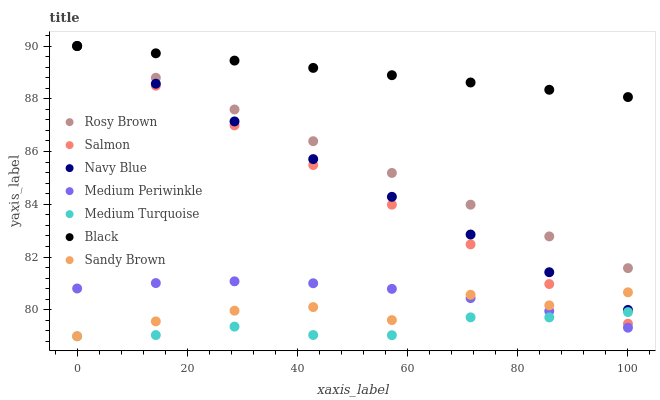Does Medium Turquoise have the minimum area under the curve?
Answer yes or no. Yes. Does Black have the maximum area under the curve?
Answer yes or no. Yes. Does Navy Blue have the minimum area under the curve?
Answer yes or no. No. Does Navy Blue have the maximum area under the curve?
Answer yes or no. No. Is Rosy Brown the smoothest?
Answer yes or no. Yes. Is Sandy Brown the roughest?
Answer yes or no. Yes. Is Navy Blue the smoothest?
Answer yes or no. No. Is Navy Blue the roughest?
Answer yes or no. No. Does Medium Turquoise have the lowest value?
Answer yes or no. Yes. Does Navy Blue have the lowest value?
Answer yes or no. No. Does Black have the highest value?
Answer yes or no. Yes. Does Medium Turquoise have the highest value?
Answer yes or no. No. Is Sandy Brown less than Rosy Brown?
Answer yes or no. Yes. Is Navy Blue greater than Medium Turquoise?
Answer yes or no. Yes. Does Navy Blue intersect Rosy Brown?
Answer yes or no. Yes. Is Navy Blue less than Rosy Brown?
Answer yes or no. No. Is Navy Blue greater than Rosy Brown?
Answer yes or no. No. Does Sandy Brown intersect Rosy Brown?
Answer yes or no. No. 